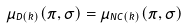Convert formula to latex. <formula><loc_0><loc_0><loc_500><loc_500>\mu _ { D ( k ) } ( \pi , \sigma ) = \mu _ { N C ( k ) } ( \pi , \sigma )</formula> 